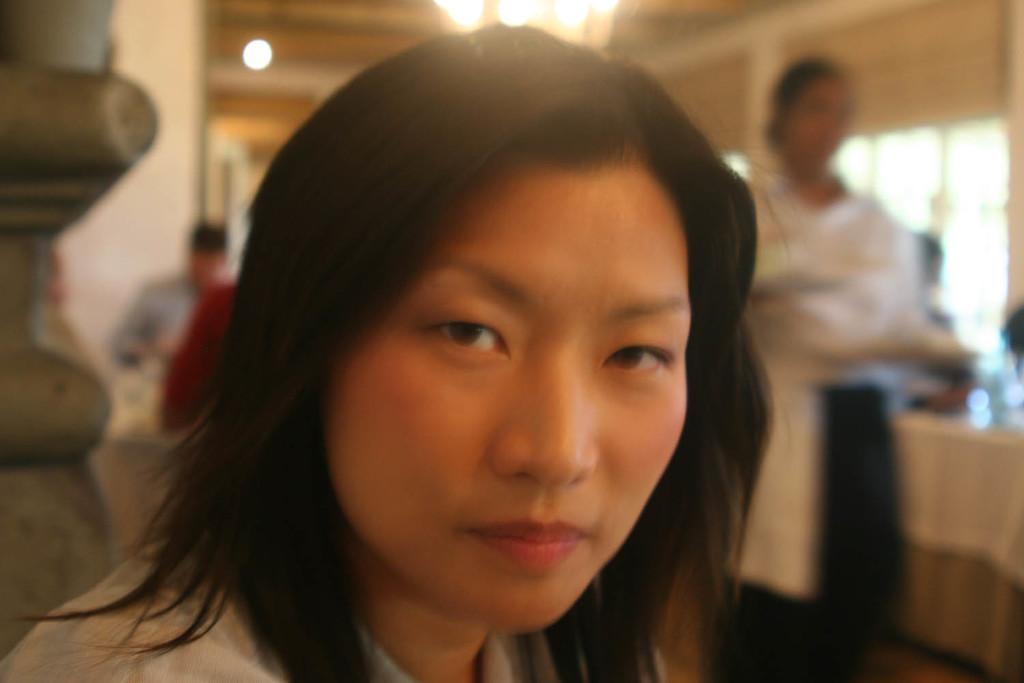Please provide a concise description of this image. In this picture there is a woman who is wearing white dress. She is sitting near to the wall. On the right there is another woman who is the wearing the white shirt, black trouser and she is holding a tray, beside her we can see some peoples were sitting near to the table. At the top there is a chandelier. On the left there is a man who is standing near to the wall. On the right background there is a window. 